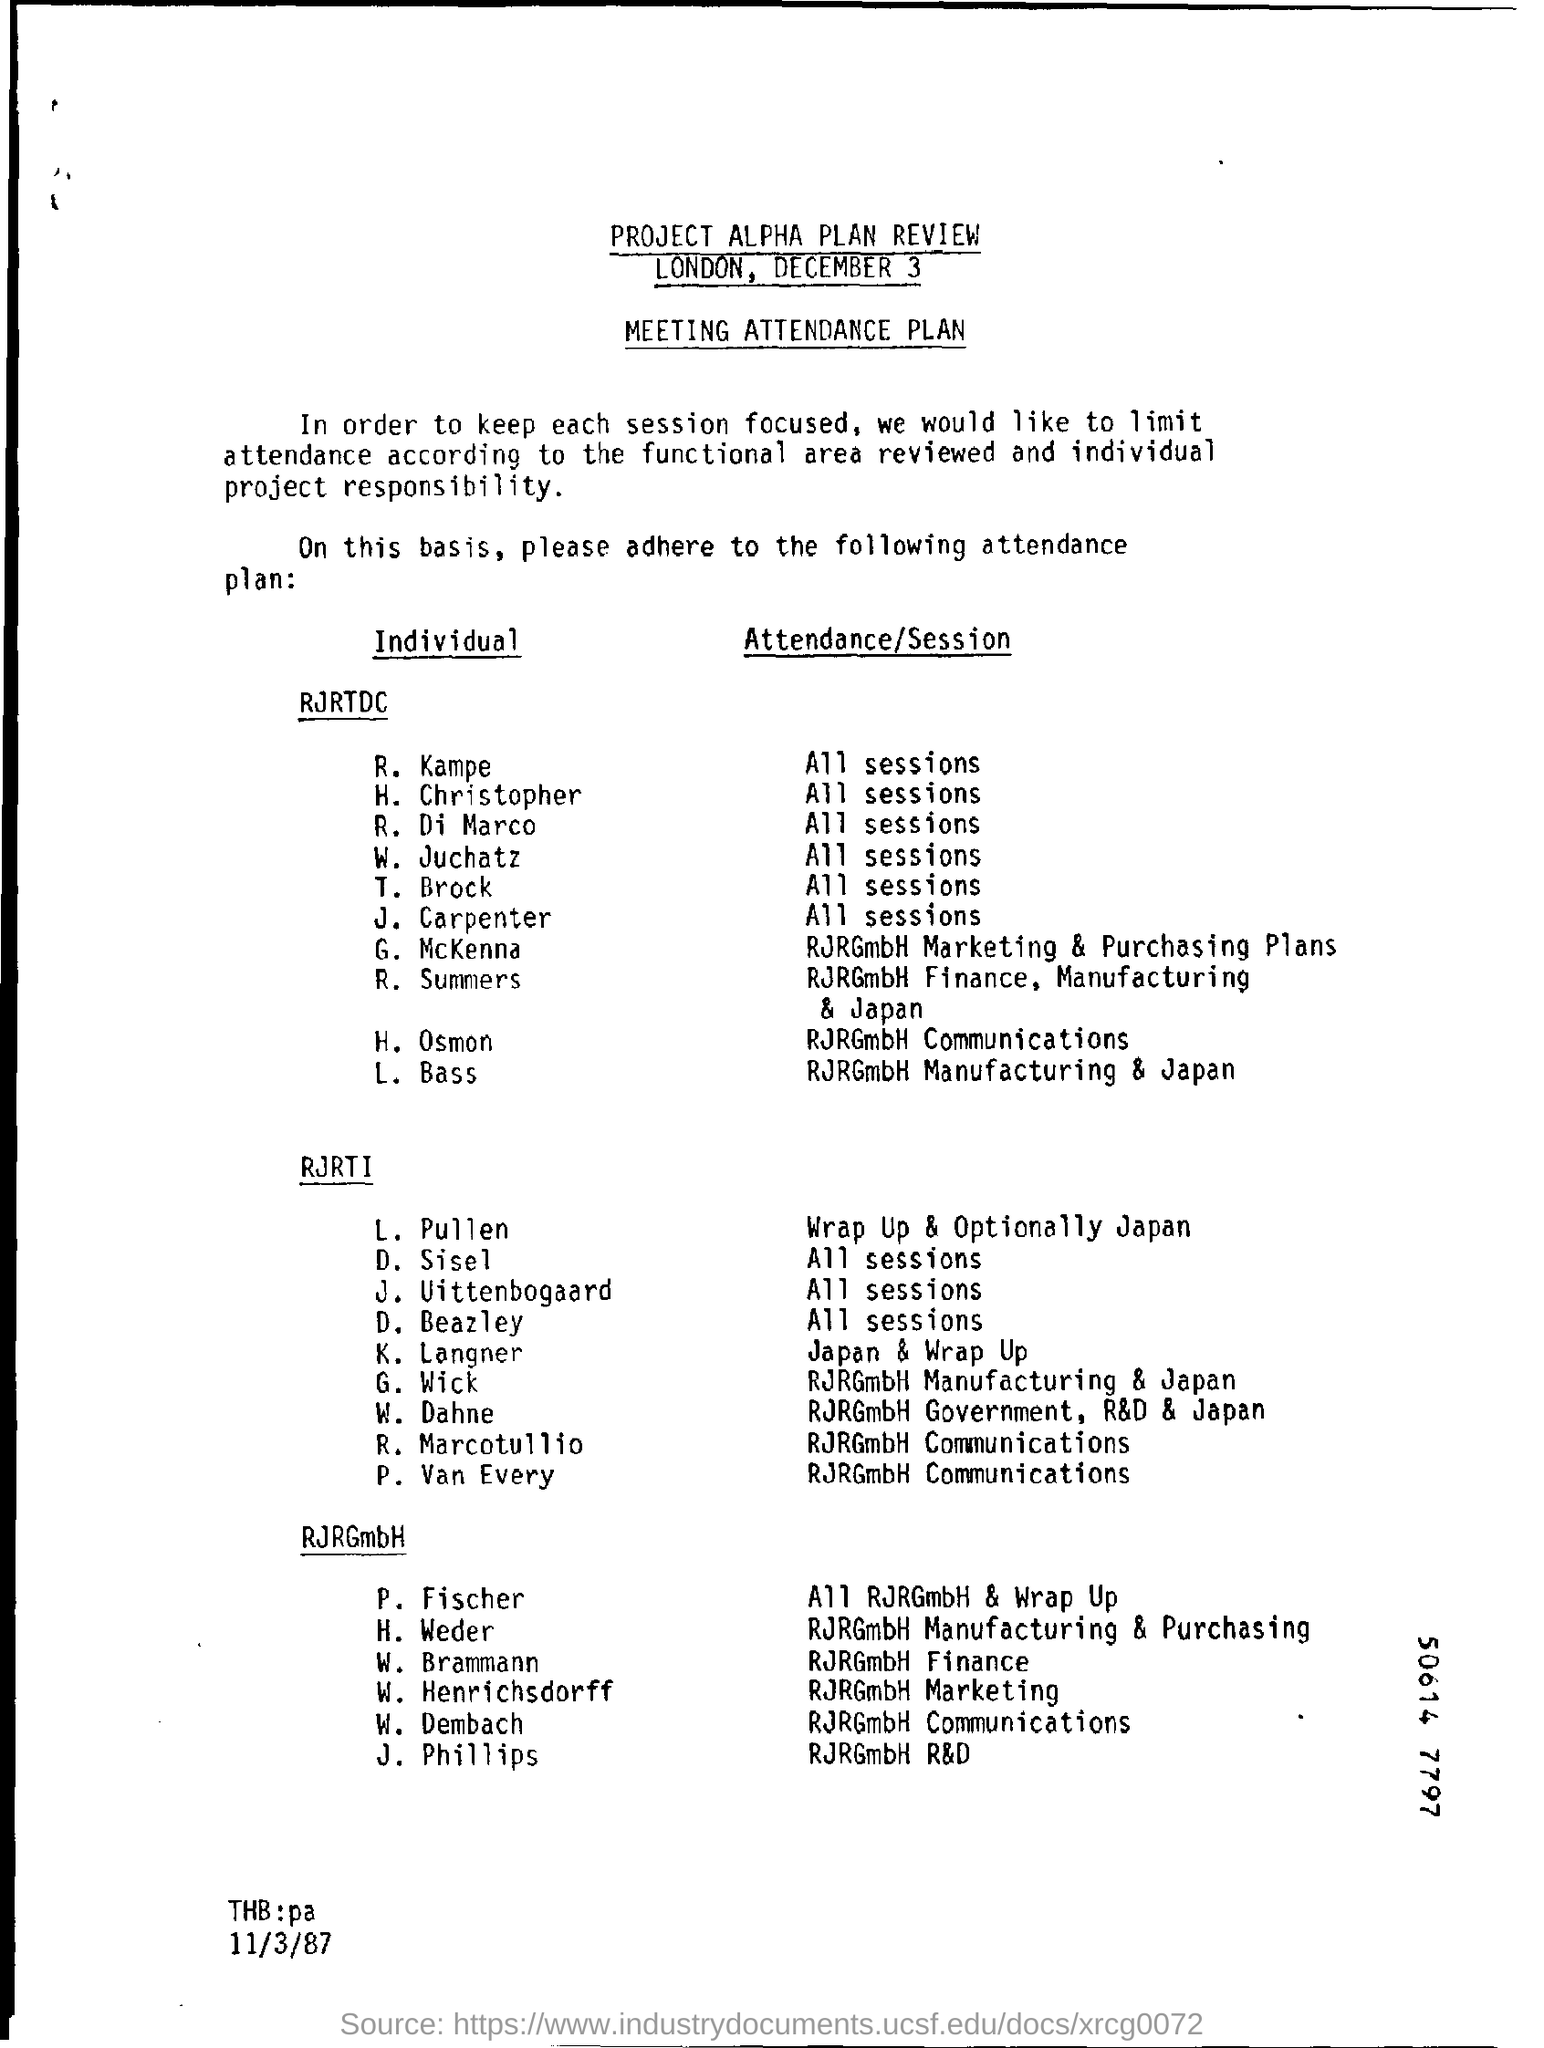Outline some significant characteristics in this image. R. Summers attended the RJRRGmbH Finance Manufacturing & Japan session of RJRTDC. 